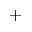<formula> <loc_0><loc_0><loc_500><loc_500>+</formula> 